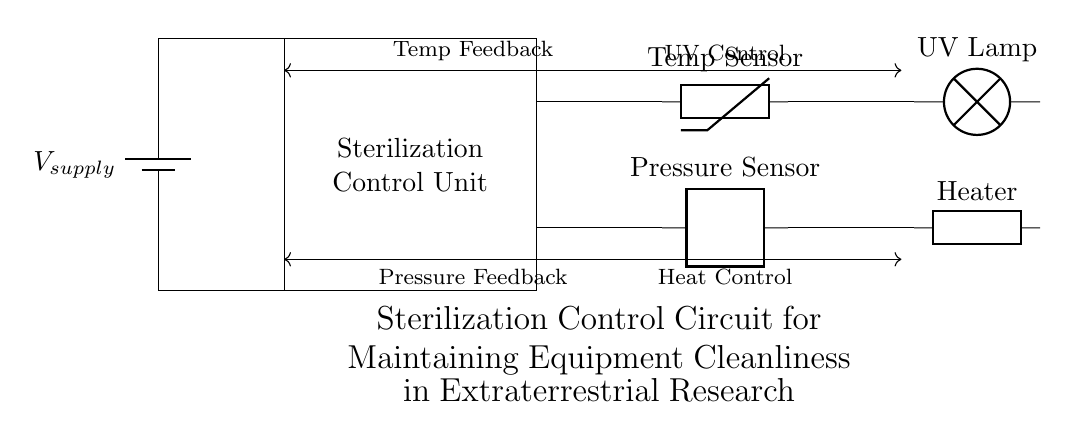What is the main purpose of the circuit? The circuit is designed to maintain equipment cleanliness in extraterrestrial research by controlling sterilization.
Answer: Maintaining equipment cleanliness What component is primarily responsible for sterilization? The UV lamp is the main component responsible for sterilization in this circuit.
Answer: UV Lamp How many sensors are present in the circuit? There are two sensors: a temperature sensor and a pressure sensor.
Answer: Two What type of feedback does the circuit use? The circuit uses temperature and pressure feedback to regulate its operations.
Answer: Temperature and pressure feedback What does the control signal from the Sterilization Control Unit direct? The control signals direct operations for UV control and heat control for sterilization purposes.
Answer: UV and heat control What kind of power supply is used in this circuit? The power supply is a battery, providing the necessary voltage for operation.
Answer: Battery 